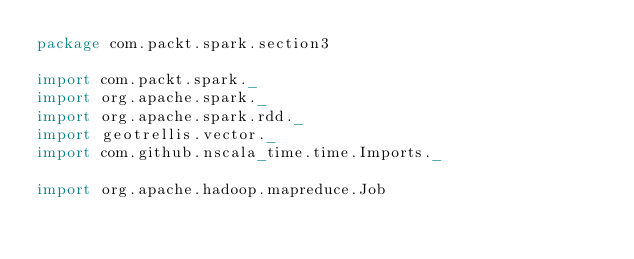<code> <loc_0><loc_0><loc_500><loc_500><_Scala_>package com.packt.spark.section3

import com.packt.spark._
import org.apache.spark._
import org.apache.spark.rdd._
import geotrellis.vector._
import com.github.nscala_time.time.Imports._

import org.apache.hadoop.mapreduce.Job</code> 